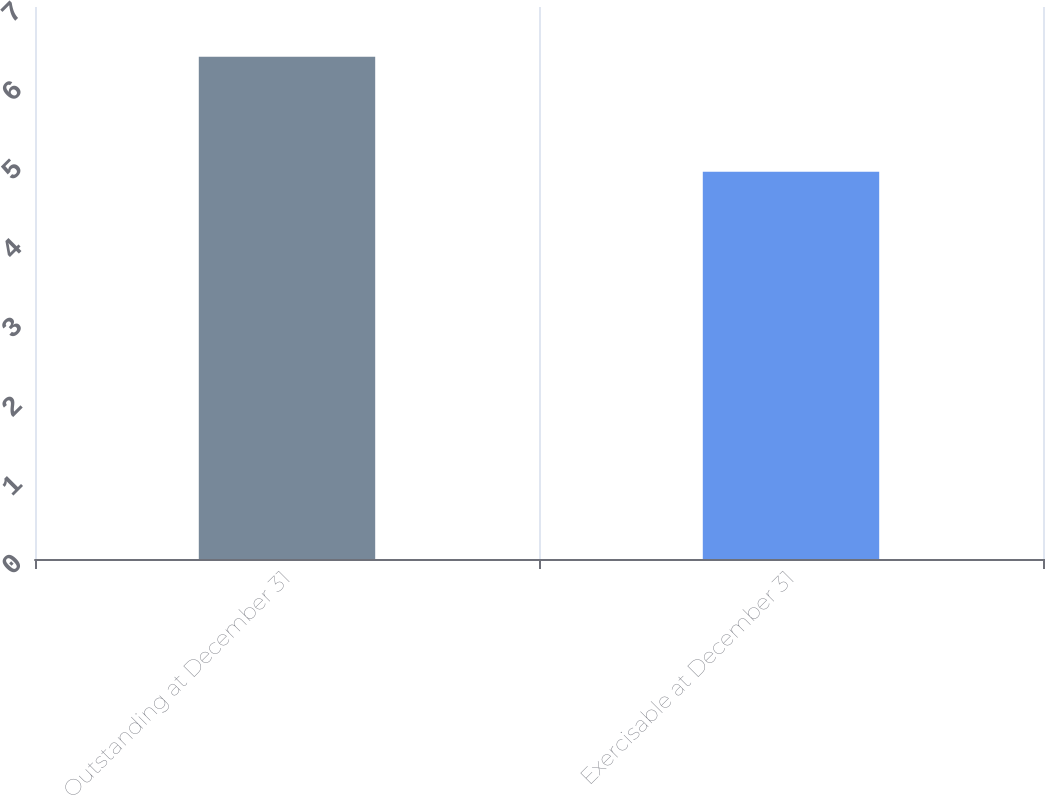Convert chart. <chart><loc_0><loc_0><loc_500><loc_500><bar_chart><fcel>Outstanding at December 31<fcel>Exercisable at December 31<nl><fcel>6.37<fcel>4.91<nl></chart> 